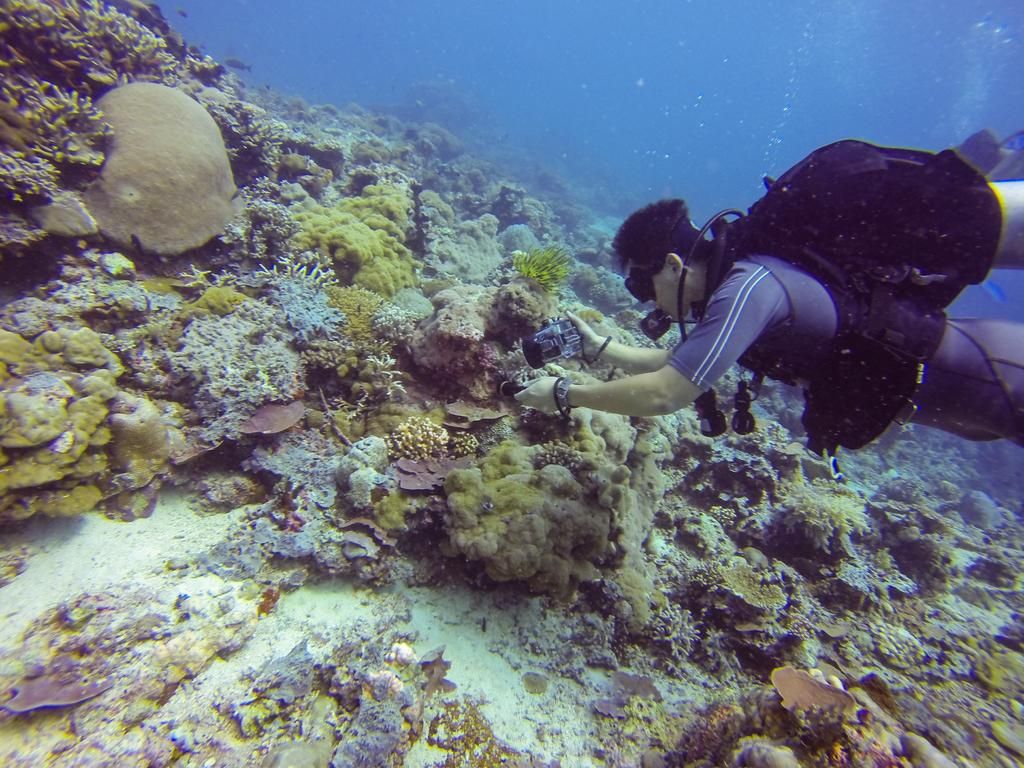What is the main subject of the image? There is a person in the image. What is the person doing in the image? The person is holding an object and is in the water. What can be seen in the water besides the person? There are water plants visible in the image. What type of rice can be seen growing in the water in the image? There is no rice visible in the image; it features a person in the water with water plants. What kind of pest is causing trouble for the town in the image? There is no town or pest mentioned in the image; it only shows a person in the water with water plants. 